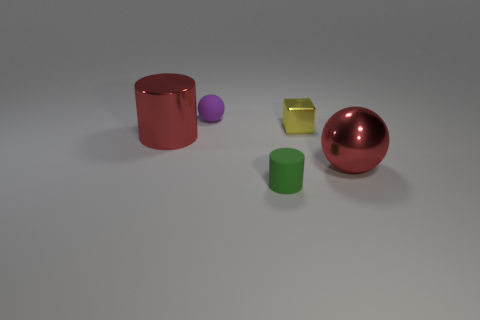There is a shiny thing to the left of the green cylinder; is its color the same as the metallic sphere?
Offer a terse response. Yes. Are there any big spheres that have the same color as the large metal cylinder?
Make the answer very short. Yes. There is a big red thing that is behind the red thing that is to the right of the yellow metallic thing; what is its material?
Your response must be concise. Metal. Do the yellow metallic object and the green matte object have the same size?
Provide a short and direct response. Yes. What number of things are rubber things on the left side of the small cylinder or big shiny objects?
Make the answer very short. 3. There is a tiny rubber object behind the big object that is to the right of the tiny purple rubber object; what shape is it?
Your response must be concise. Sphere. There is a yellow thing; is it the same size as the cylinder that is to the right of the red cylinder?
Keep it short and to the point. Yes. What is the material of the cylinder that is behind the tiny green rubber cylinder?
Ensure brevity in your answer.  Metal. How many objects are behind the small yellow metal object and left of the tiny purple object?
Offer a terse response. 0. There is a red ball that is the same size as the shiny cylinder; what is its material?
Make the answer very short. Metal. 